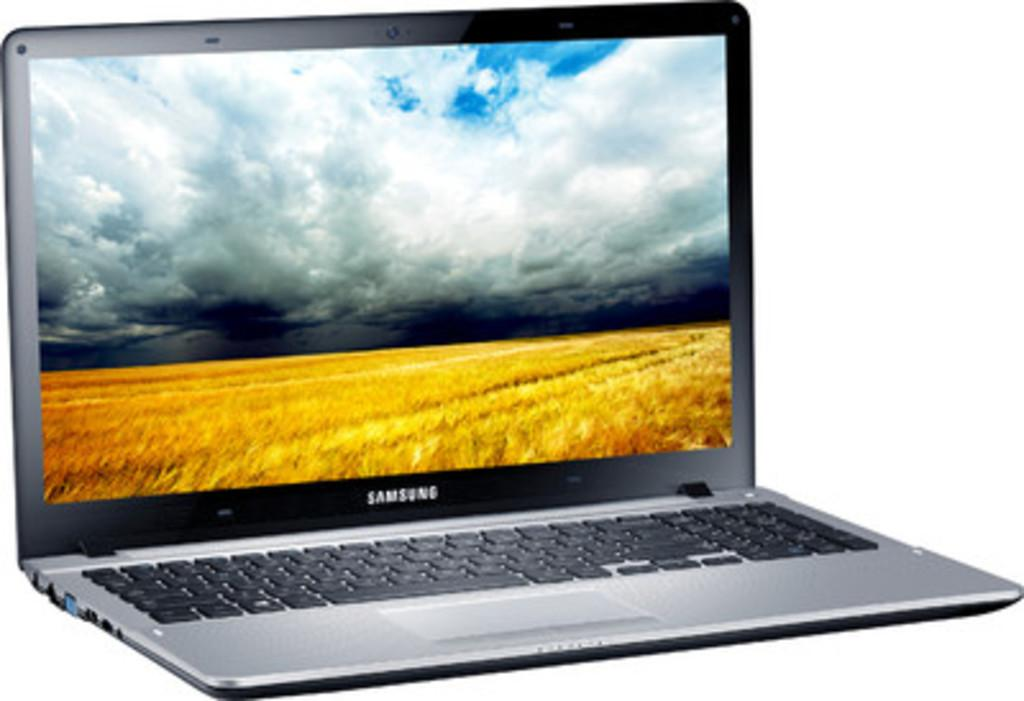<image>
Summarize the visual content of the image. A samsung brand laptop computer with a field on the screen. 